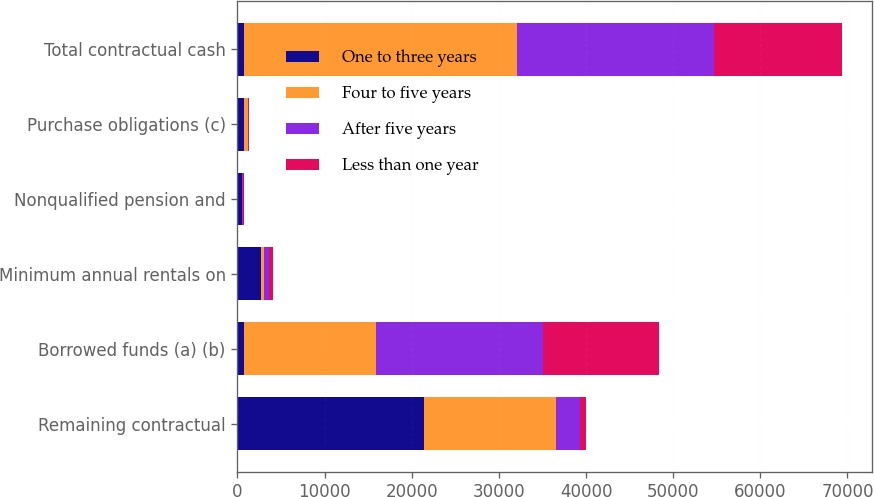<chart> <loc_0><loc_0><loc_500><loc_500><stacked_bar_chart><ecel><fcel>Remaining contractual<fcel>Borrowed funds (a) (b)<fcel>Minimum annual rentals on<fcel>Nonqualified pension and<fcel>Purchase obligations (c)<fcel>Total contractual cash<nl><fcel>One to three years<fcel>21396<fcel>698.5<fcel>2655<fcel>519<fcel>703<fcel>698.5<nl><fcel>Four to five years<fcel>15185<fcel>15243<fcel>376<fcel>56<fcel>468<fcel>31328<nl><fcel>After five years<fcel>2709<fcel>19116<fcel>622<fcel>109<fcel>144<fcel>22700<nl><fcel>Less than one year<fcel>694<fcel>13291<fcel>478<fcel>108<fcel>63<fcel>14634<nl></chart> 